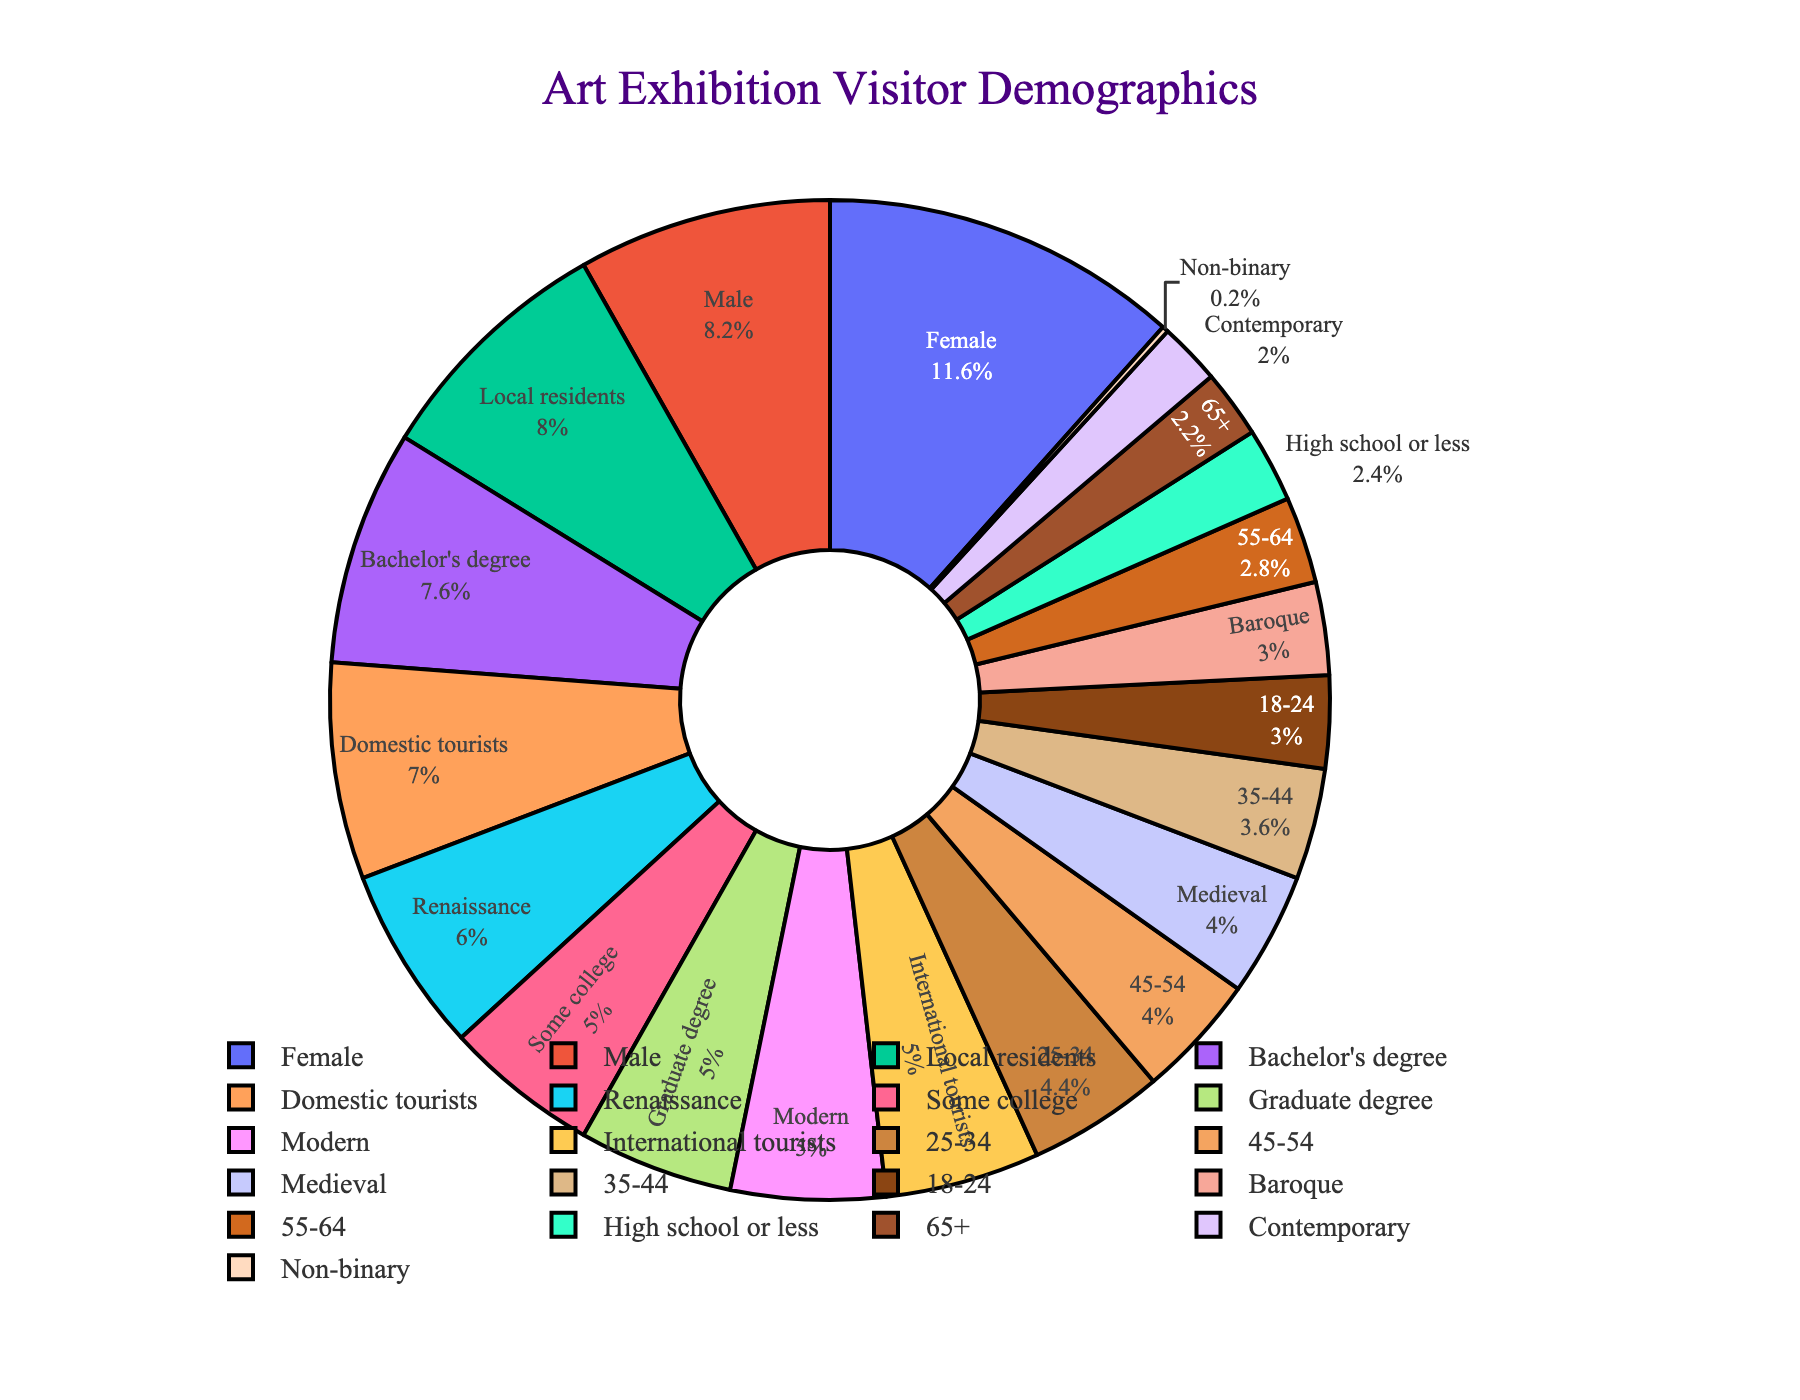what percentage of visitors are between the ages of 18-44? To find the percentage of visitors between the ages of 18-44, add the percentages for the 18-24, 25-34, and 35-44 age groups: 15% + 22% + 18% = 55%
Answer: 55% Which gender has a higher representation? Compare the percentages of each gender. Female visitors are 58%, while Male visitors are 41%, and Non-binary visitors are 1%. Female has a higher percentage.
Answer: Female How many more visitors have a Bachelor's degree or higher compared to those with only High school or less? Add the percentages of visitors with a Bachelor's degree and those with a Graduate degree: 38% + 25% = 63%. Compare this to those with High school or less: 63% - 12% = 51%.
Answer: 51% What is the most popular interest area among visitors? Look for the highest percentage in the Interest Area category. The Renaissance has 30%, which is the highest.
Answer: Renaissance Among visitors, are there more locals or international tourists? Compare the percentages of local residents (40%) and international tourists (25%). Local residents have a higher percentage.
Answer: Local residents What is the difference in percentage between visitors aged 45-54 and 55-64? Subtract the percentage of visitors aged 55-64 from those aged 45-54: 20% - 14% = 6%
Answer: 6% What is the combined percentage of visitors interested in Medieval and Baroque art? Add the percentages for Medieval and Baroque interest areas: 20% + 15% = 35%
Answer: 35% What is the ratio of domestic tourists to international tourists? Divide the percentage of domestic tourists by the percentage of international tourists: 35% / 25% = 1.4
Answer: 1.4 Which education level has the second-highest representation among visitors? Identify the highest percentage in the Education Level category and then find the second highest. Bachelor's degree is the highest at 38%, and Some college and Graduate degree are both at 25%, so they tie for the second-highest.
Answer: Some college and Graduate degree (tie) How much more frequent are female visitors compared to male visitors? Subtract the percentage of Male visitors from Female visitors: 58% - 41% = 17%
Answer: 17% 